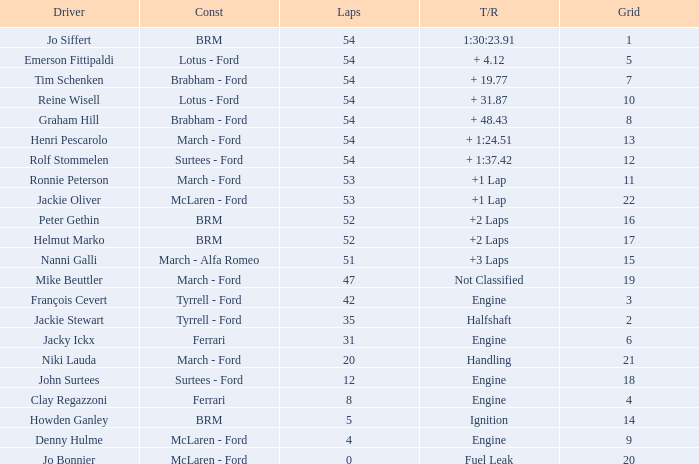Give me the full table as a dictionary. {'header': ['Driver', 'Const', 'Laps', 'T/R', 'Grid'], 'rows': [['Jo Siffert', 'BRM', '54', '1:30:23.91', '1'], ['Emerson Fittipaldi', 'Lotus - Ford', '54', '+ 4.12', '5'], ['Tim Schenken', 'Brabham - Ford', '54', '+ 19.77', '7'], ['Reine Wisell', 'Lotus - Ford', '54', '+ 31.87', '10'], ['Graham Hill', 'Brabham - Ford', '54', '+ 48.43', '8'], ['Henri Pescarolo', 'March - Ford', '54', '+ 1:24.51', '13'], ['Rolf Stommelen', 'Surtees - Ford', '54', '+ 1:37.42', '12'], ['Ronnie Peterson', 'March - Ford', '53', '+1 Lap', '11'], ['Jackie Oliver', 'McLaren - Ford', '53', '+1 Lap', '22'], ['Peter Gethin', 'BRM', '52', '+2 Laps', '16'], ['Helmut Marko', 'BRM', '52', '+2 Laps', '17'], ['Nanni Galli', 'March - Alfa Romeo', '51', '+3 Laps', '15'], ['Mike Beuttler', 'March - Ford', '47', 'Not Classified', '19'], ['François Cevert', 'Tyrrell - Ford', '42', 'Engine', '3'], ['Jackie Stewart', 'Tyrrell - Ford', '35', 'Halfshaft', '2'], ['Jacky Ickx', 'Ferrari', '31', 'Engine', '6'], ['Niki Lauda', 'March - Ford', '20', 'Handling', '21'], ['John Surtees', 'Surtees - Ford', '12', 'Engine', '18'], ['Clay Regazzoni', 'Ferrari', '8', 'Engine', '4'], ['Howden Ganley', 'BRM', '5', 'Ignition', '14'], ['Denny Hulme', 'McLaren - Ford', '4', 'Engine', '9'], ['Jo Bonnier', 'McLaren - Ford', '0', 'Fuel Leak', '20']]} How many laps for a grid larger than 1 with a Time/Retired of halfshaft? 35.0. 